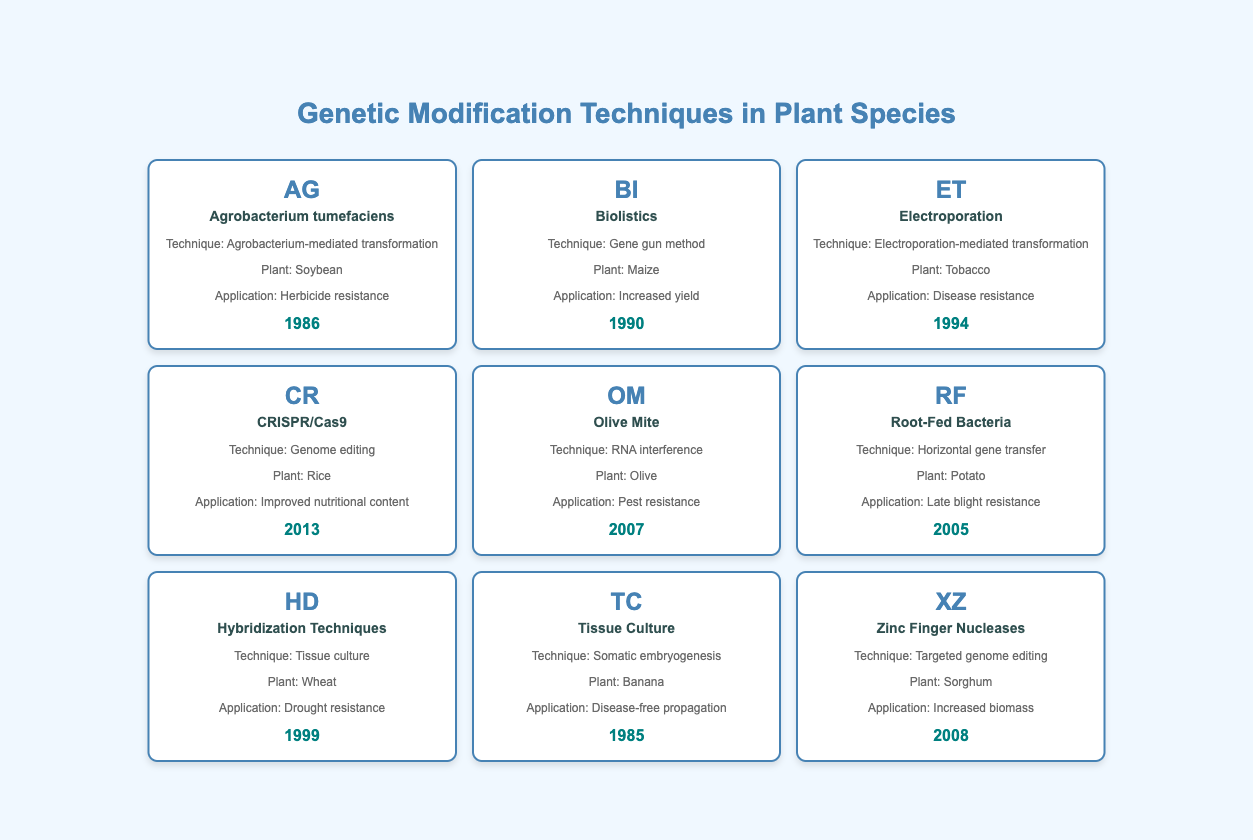What genetic modification technique was first introduced for Soybean? The table shows that the genetic modification technique for Soybean is "Agrobacterium-mediated transformation," introduced in 1986.
Answer: Agrobacterium-mediated transformation Which plant species was modified using the Gene gun method? According to the table, the Gene gun method is used for modifying Maize.
Answer: Maize Is CRISPR/Cas9 used for improving nutritional content in Rice? The table states that CRISPR/Cas9 is specifically associated with improving the nutritional content of Rice. Therefore, the answer is yes.
Answer: Yes What is the application of the technique used for Olive? The table indicates that RNA interference is the technique used for Olive, with the application being pest resistance.
Answer: Pest resistance Which technique was introduced in 1999, and what is its plant species? The table shows that Hybridization Techniques, specifically tissue culture, was introduced in 1999 for Wheat.
Answer: Hybridization Techniques (Wheat) How many techniques were introduced after 2005? The techniques introduced after 2005 are: CRISPR/Cas9 (2013), Olive Mite (2007), and Zinc Finger Nucleases (2008). This gives a total of 3 techniques.
Answer: 3 Is there any genetic modification technique listed for Banana? Yes, the table indicates that the technique used for Banana is Somatic embryogenesis.
Answer: Yes What is the earliest year introduced for a genetic modification technique in this table? By looking at the introduction years, the earliest year is 1985, when the technique Somatic embryogenesis was introduced for Banana.
Answer: 1985 What plant species was modified for increased yield using the method listed in 1990? The table states that the method used in 1990 is the Gene gun method, and it was applied to Maize for increased yield.
Answer: Maize 